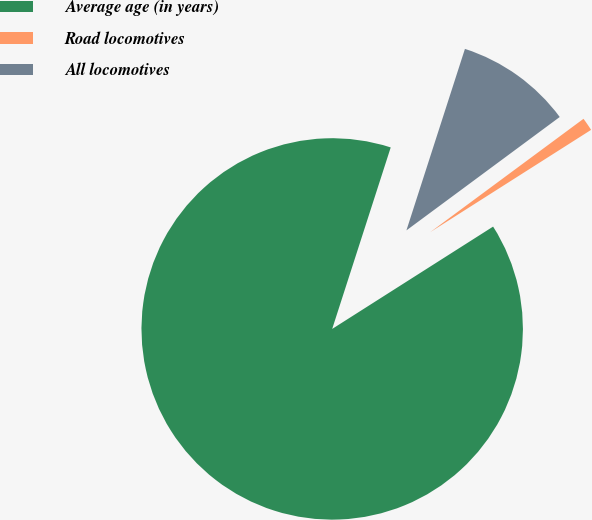Convert chart to OTSL. <chart><loc_0><loc_0><loc_500><loc_500><pie_chart><fcel>Average age (in years)<fcel>Road locomotives<fcel>All locomotives<nl><fcel>88.98%<fcel>1.12%<fcel>9.9%<nl></chart> 